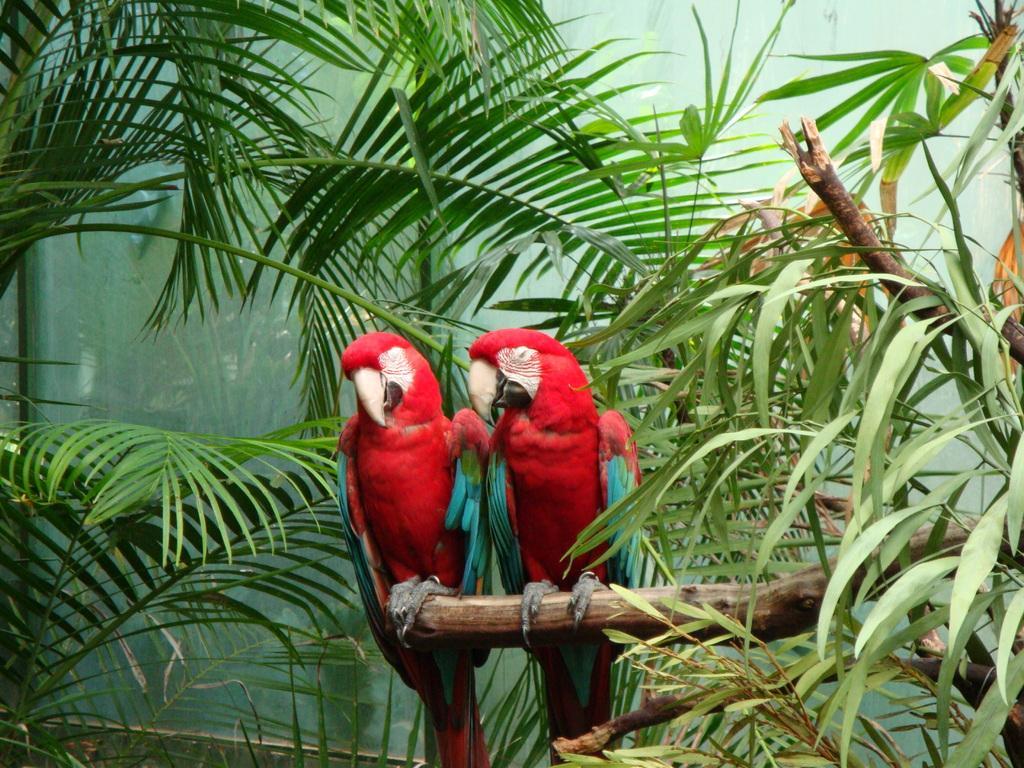Can you describe this image briefly? In this picture in the front there are parrots standing on a branch of a tree. In the background there are leaves and there is glass. 